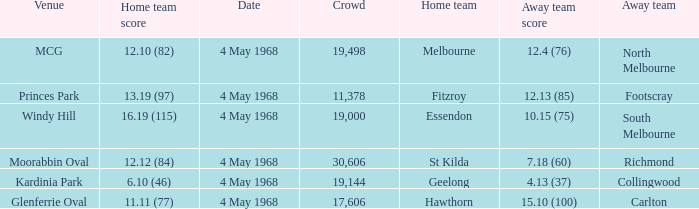What home team played at MCG? North Melbourne. Can you parse all the data within this table? {'header': ['Venue', 'Home team score', 'Date', 'Crowd', 'Home team', 'Away team score', 'Away team'], 'rows': [['MCG', '12.10 (82)', '4 May 1968', '19,498', 'Melbourne', '12.4 (76)', 'North Melbourne'], ['Princes Park', '13.19 (97)', '4 May 1968', '11,378', 'Fitzroy', '12.13 (85)', 'Footscray'], ['Windy Hill', '16.19 (115)', '4 May 1968', '19,000', 'Essendon', '10.15 (75)', 'South Melbourne'], ['Moorabbin Oval', '12.12 (84)', '4 May 1968', '30,606', 'St Kilda', '7.18 (60)', 'Richmond'], ['Kardinia Park', '6.10 (46)', '4 May 1968', '19,144', 'Geelong', '4.13 (37)', 'Collingwood'], ['Glenferrie Oval', '11.11 (77)', '4 May 1968', '17,606', 'Hawthorn', '15.10 (100)', 'Carlton']]} 